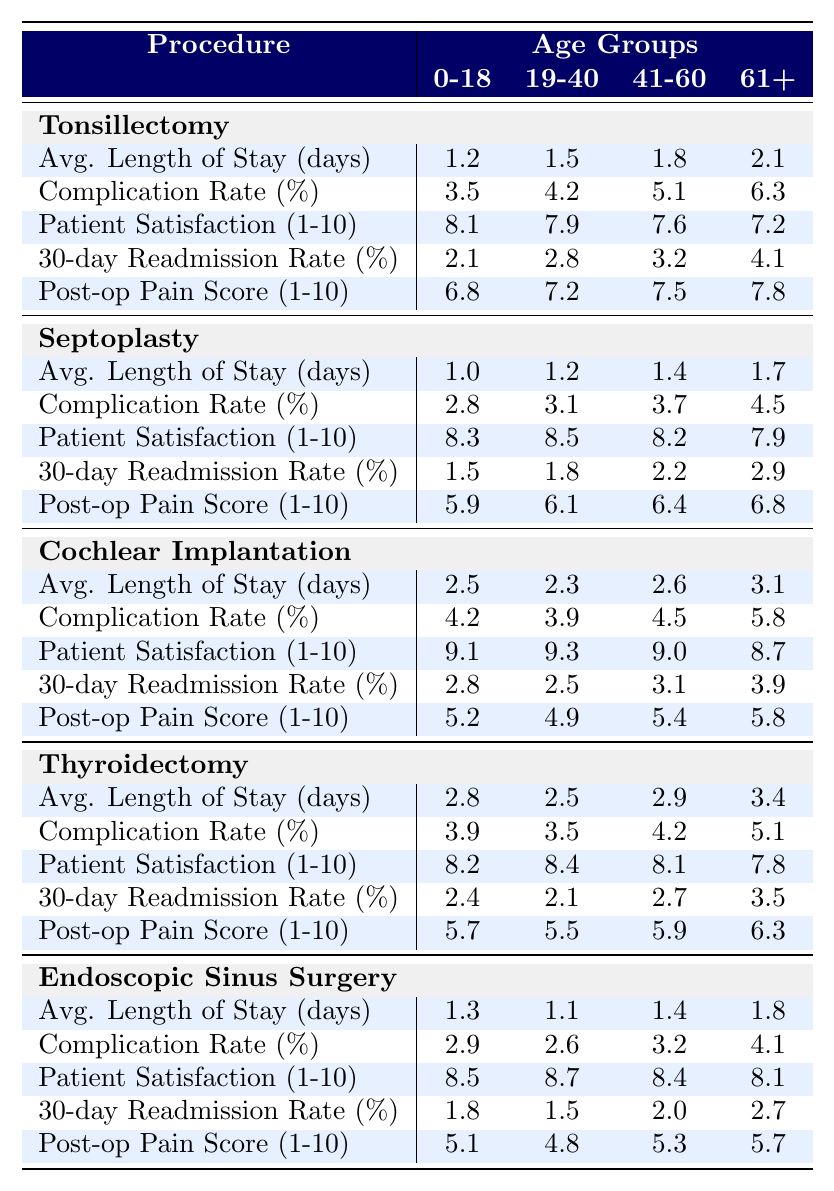What is the average length of stay for patients aged 61+ undergoing Tonsillectomy? According to the table, the average length of stay for patients aged 61+ undergoing Tonsillectomy is 2.1 days.
Answer: 2.1 days Which age group has the highest complication rate for Septoplasty? The highest complication rate for Septoplasty is 4.5%, which occurs in the 61+ age group according to the table.
Answer: 61+ What is the patient satisfaction score for Cochlear Implantation in the 19-40 age group? The patient satisfaction score for Cochlear Implantation in the 19-40 age group is 9.3, as shown in the table.
Answer: 9.3 Calculate the difference in average length of stay between patients aged 0-18 and those aged 41-60 for Thyroidectomy. For Thyroidectomy, the average length of stay for 0-18 is 2.8 days and for 41-60 is 2.9 days. The difference is 2.9 - 2.8 = 0.1 days.
Answer: 0.1 days Is the patient satisfaction score for Endoscopic Sinus Surgery higher in the 19-40 age group compared to the 61+ age group? The patient satisfaction score for Endoscopic Sinus Surgery in the 19-40 age group is 8.7, while in the 61+ age group it is 8.1. Since 8.7 > 8.1, the score is indeed higher in the younger age group.
Answer: Yes What is the average post-operative pain score for patients aged 41-60 who underwent Septoplasty? The average post-operative pain score for patients aged 41-60 who underwent Septoplasty is 6.4, as reported in the table.
Answer: 6.4 Which procedure has the lowest average post-operative pain score for the age group 0-18? Looking at the data, the procedure with the lowest average post-operative pain score for the age group 0-18 is Endoscopic Sinus Surgery with a score of 5.1.
Answer: Endoscopic Sinus Surgery What is the average complication rate across all age groups for Cochlear Implantation? For Cochlear Implantation, the average complication rates across all age groups are 4.2%, 3.9%, 4.5%, and 5.8%. The average is (4.2+3.9+4.5+5.8)/4 = 4.35%.
Answer: 4.35% Compare the average patient satisfaction score between Tonsillectomy and Thyroidectomy for the 41-60 age group. For Tonsillectomy, the average patient satisfaction score for the 41-60 age group is 7.6, and for Thyroidectomy, it is 8.1. Comparing these, 8.1 is higher than 7.6, indicating greater satisfaction with Thyroidectomy.
Answer: Thyroidectomy is higher What is the trend in the 30-day readmission rate as age increases for Tonsillectomy? As age increases for Tonsillectomy, the 30-day readmission rate goes from 2.1% (0-18) to 4.1% (61+), indicating an increasing trend in readmissions as age increases.
Answer: Increasing trend 